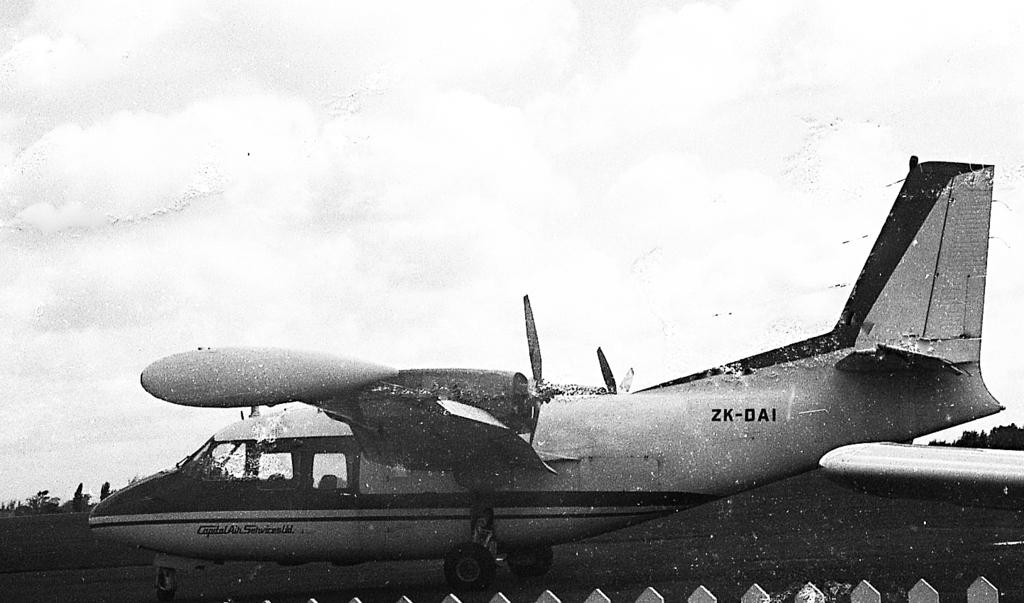<image>
Relay a brief, clear account of the picture shown. A plane is in the air with ZK-DAI on the side. 